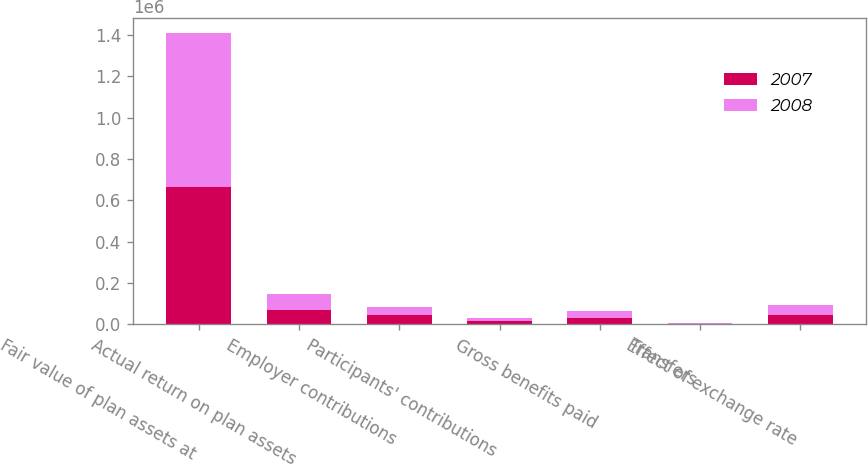Convert chart. <chart><loc_0><loc_0><loc_500><loc_500><stacked_bar_chart><ecel><fcel>Fair value of plan assets at<fcel>Actual return on plan assets<fcel>Employer contributions<fcel>Participants' contributions<fcel>Gross benefits paid<fcel>Transfers<fcel>Effect of exchange rate<nl><fcel>2007<fcel>664699<fcel>67247<fcel>47046<fcel>15518<fcel>29565<fcel>2679<fcel>46581<nl><fcel>2008<fcel>746189<fcel>81483<fcel>34937<fcel>14367<fcel>32486<fcel>1868<fcel>44930<nl></chart> 